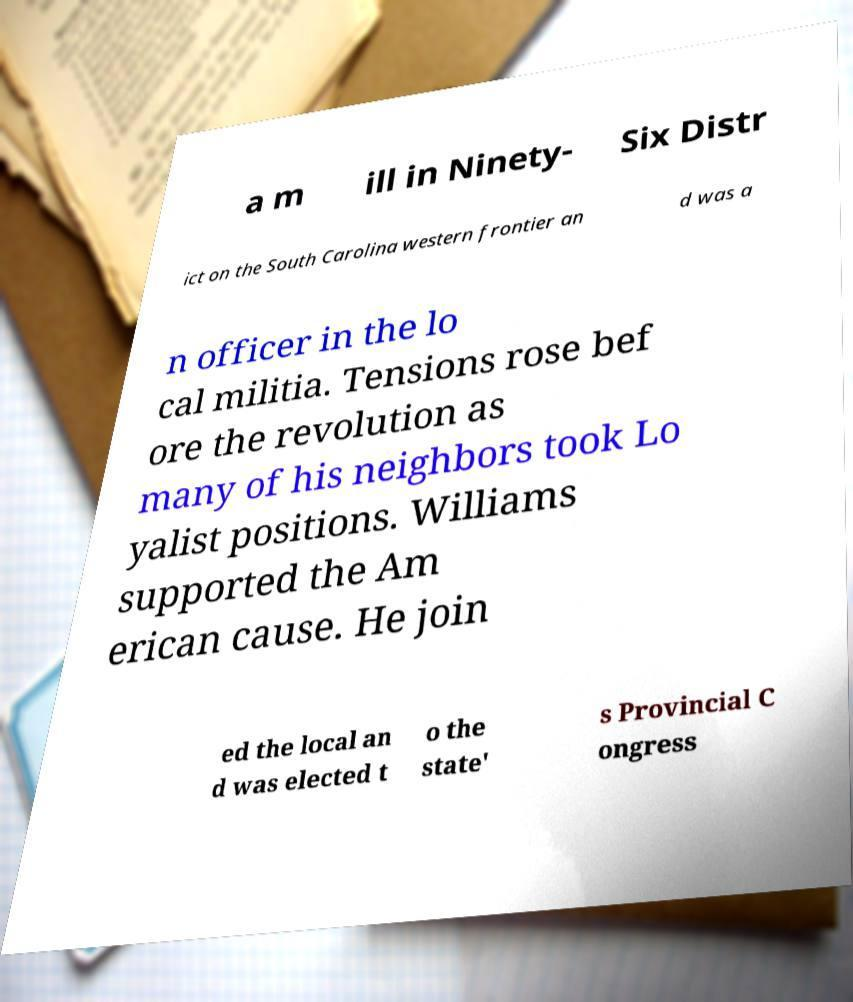Please read and relay the text visible in this image. What does it say? a m ill in Ninety- Six Distr ict on the South Carolina western frontier an d was a n officer in the lo cal militia. Tensions rose bef ore the revolution as many of his neighbors took Lo yalist positions. Williams supported the Am erican cause. He join ed the local an d was elected t o the state' s Provincial C ongress 